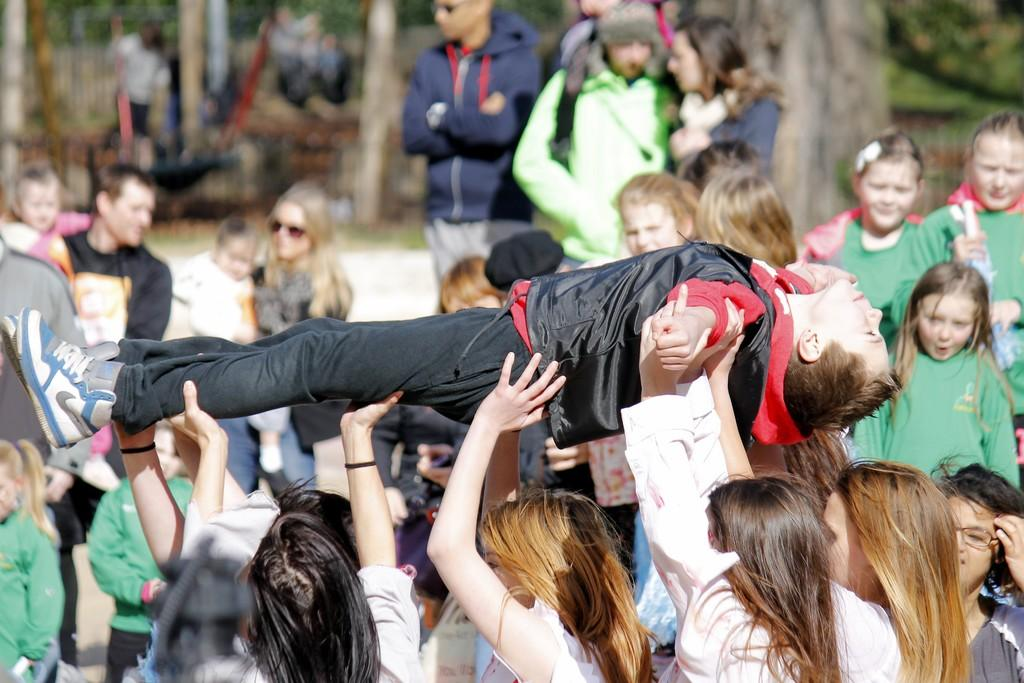How many people are in the image? There is a group of people in the image. What are some people doing in the image? Some people are lifting another person. What can be seen in the background of the image? There are trees visible in the image. What type of honey is being used by the cook in the image? There is no cook or honey present in the image. What insect can be seen flying around the person being lifted? There are no insects visible in the image. 